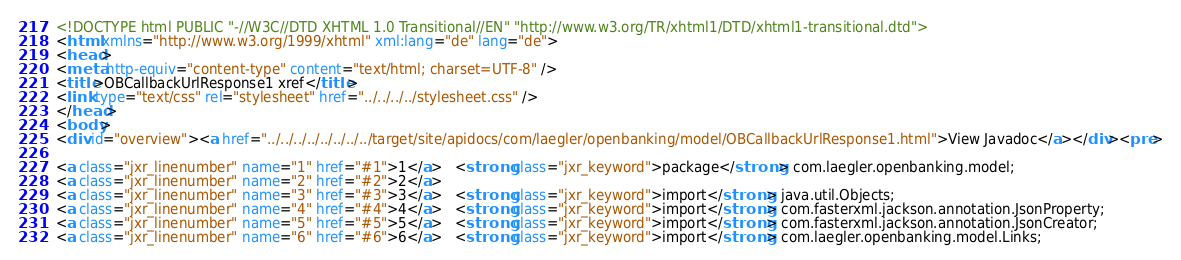Convert code to text. <code><loc_0><loc_0><loc_500><loc_500><_HTML_><!DOCTYPE html PUBLIC "-//W3C//DTD XHTML 1.0 Transitional//EN" "http://www.w3.org/TR/xhtml1/DTD/xhtml1-transitional.dtd">
<html xmlns="http://www.w3.org/1999/xhtml" xml:lang="de" lang="de">
<head>
<meta http-equiv="content-type" content="text/html; charset=UTF-8" />
<title>OBCallbackUrlResponse1 xref</title>
<link type="text/css" rel="stylesheet" href="../../../../stylesheet.css" />
</head>
<body>
<div id="overview"><a href="../../../../../../../../target/site/apidocs/com/laegler/openbanking/model/OBCallbackUrlResponse1.html">View Javadoc</a></div><pre>

<a class="jxr_linenumber" name="1" href="#1">1</a>   <strong class="jxr_keyword">package</strong> com.laegler.openbanking.model;
<a class="jxr_linenumber" name="2" href="#2">2</a>   
<a class="jxr_linenumber" name="3" href="#3">3</a>   <strong class="jxr_keyword">import</strong> java.util.Objects;
<a class="jxr_linenumber" name="4" href="#4">4</a>   <strong class="jxr_keyword">import</strong> com.fasterxml.jackson.annotation.JsonProperty;
<a class="jxr_linenumber" name="5" href="#5">5</a>   <strong class="jxr_keyword">import</strong> com.fasterxml.jackson.annotation.JsonCreator;
<a class="jxr_linenumber" name="6" href="#6">6</a>   <strong class="jxr_keyword">import</strong> com.laegler.openbanking.model.Links;</code> 